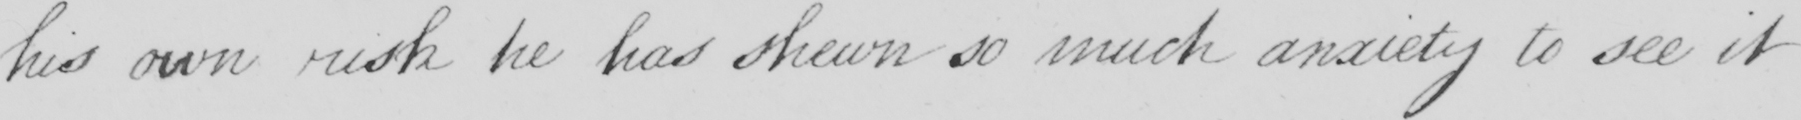Can you read and transcribe this handwriting? his own risk he has shewn so much anxiety to see it 